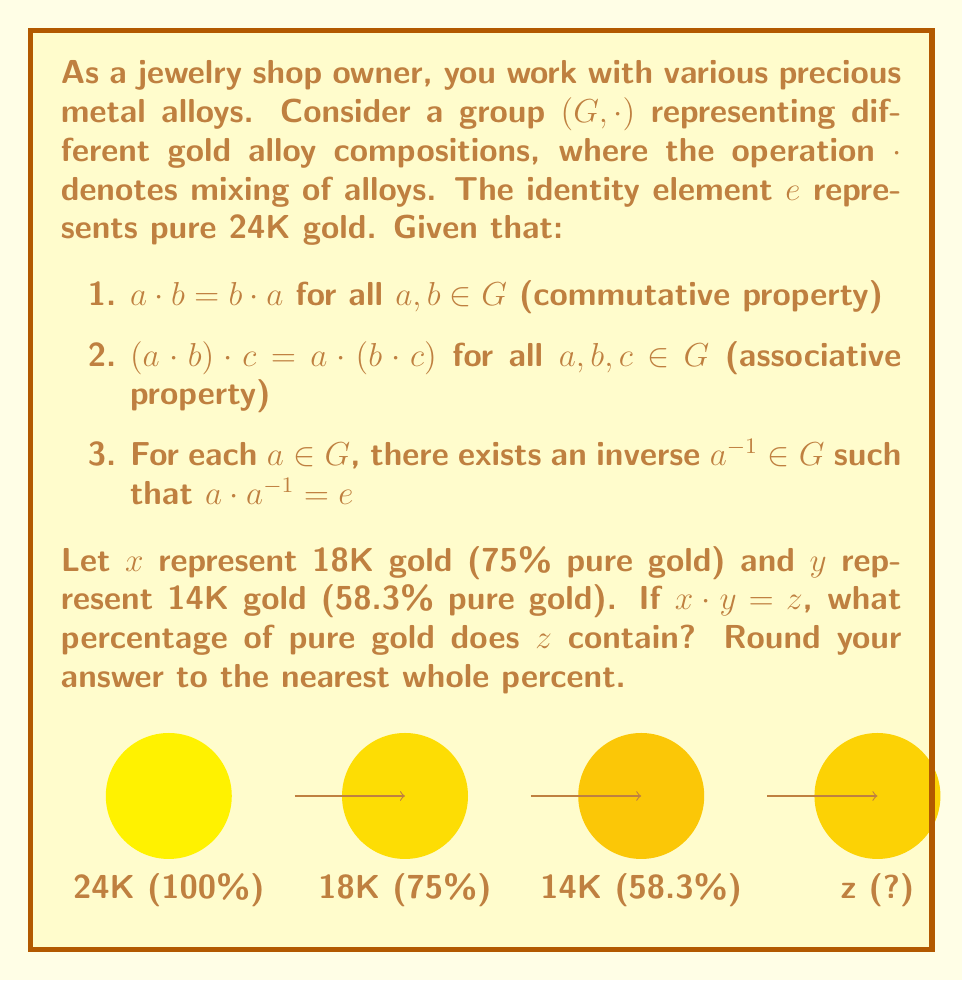What is the answer to this math problem? Let's approach this step-by-step:

1) First, we need to understand what the operation $\cdot$ means in terms of gold purity. When we mix two alloys, the resulting purity is the weighted average of the two purities.

2) Let's define a function $f: G \rightarrow [0,1]$ that maps each element of $G$ to its gold purity (as a decimal between 0 and 1).

3) For the operation $\cdot$, we can write:

   $f(a \cdot b) = \frac{f(a) + f(b)}{2}$

4) Now, we're given:
   $f(x) = 0.75$ (18K gold)
   $f(y) = 0.583$ (14K gold)

5) We need to find $f(z)$ where $z = x \cdot y$:

   $f(z) = f(x \cdot y) = \frac{f(x) + f(y)}{2}$

6) Substituting the values:

   $f(z) = \frac{0.75 + 0.583}{2} = \frac{1.333}{2} = 0.6665$

7) Converting to a percentage:

   $0.6665 \times 100\% = 66.65\%$

8) Rounding to the nearest whole percent:

   $66.65\% \approx 67\%$

Therefore, the resulting alloy $z$ contains approximately 67% pure gold.
Answer: 67% 